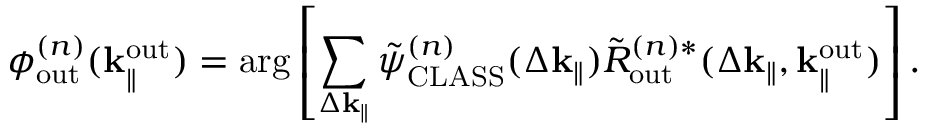<formula> <loc_0><loc_0><loc_500><loc_500>\phi _ { o u t } ^ { ( n ) } ( k _ { \| } ^ { o u t } ) = \arg \left [ \sum _ { \Delta k _ { \| } } \tilde { \psi } _ { C L A S S } ^ { ( n ) } ( \Delta k _ { \| } ) \tilde { R } _ { o u t } ^ { ( n ) \ast } ( \Delta k _ { \| } , k _ { \| } ^ { o u t } ) \right ] .</formula> 